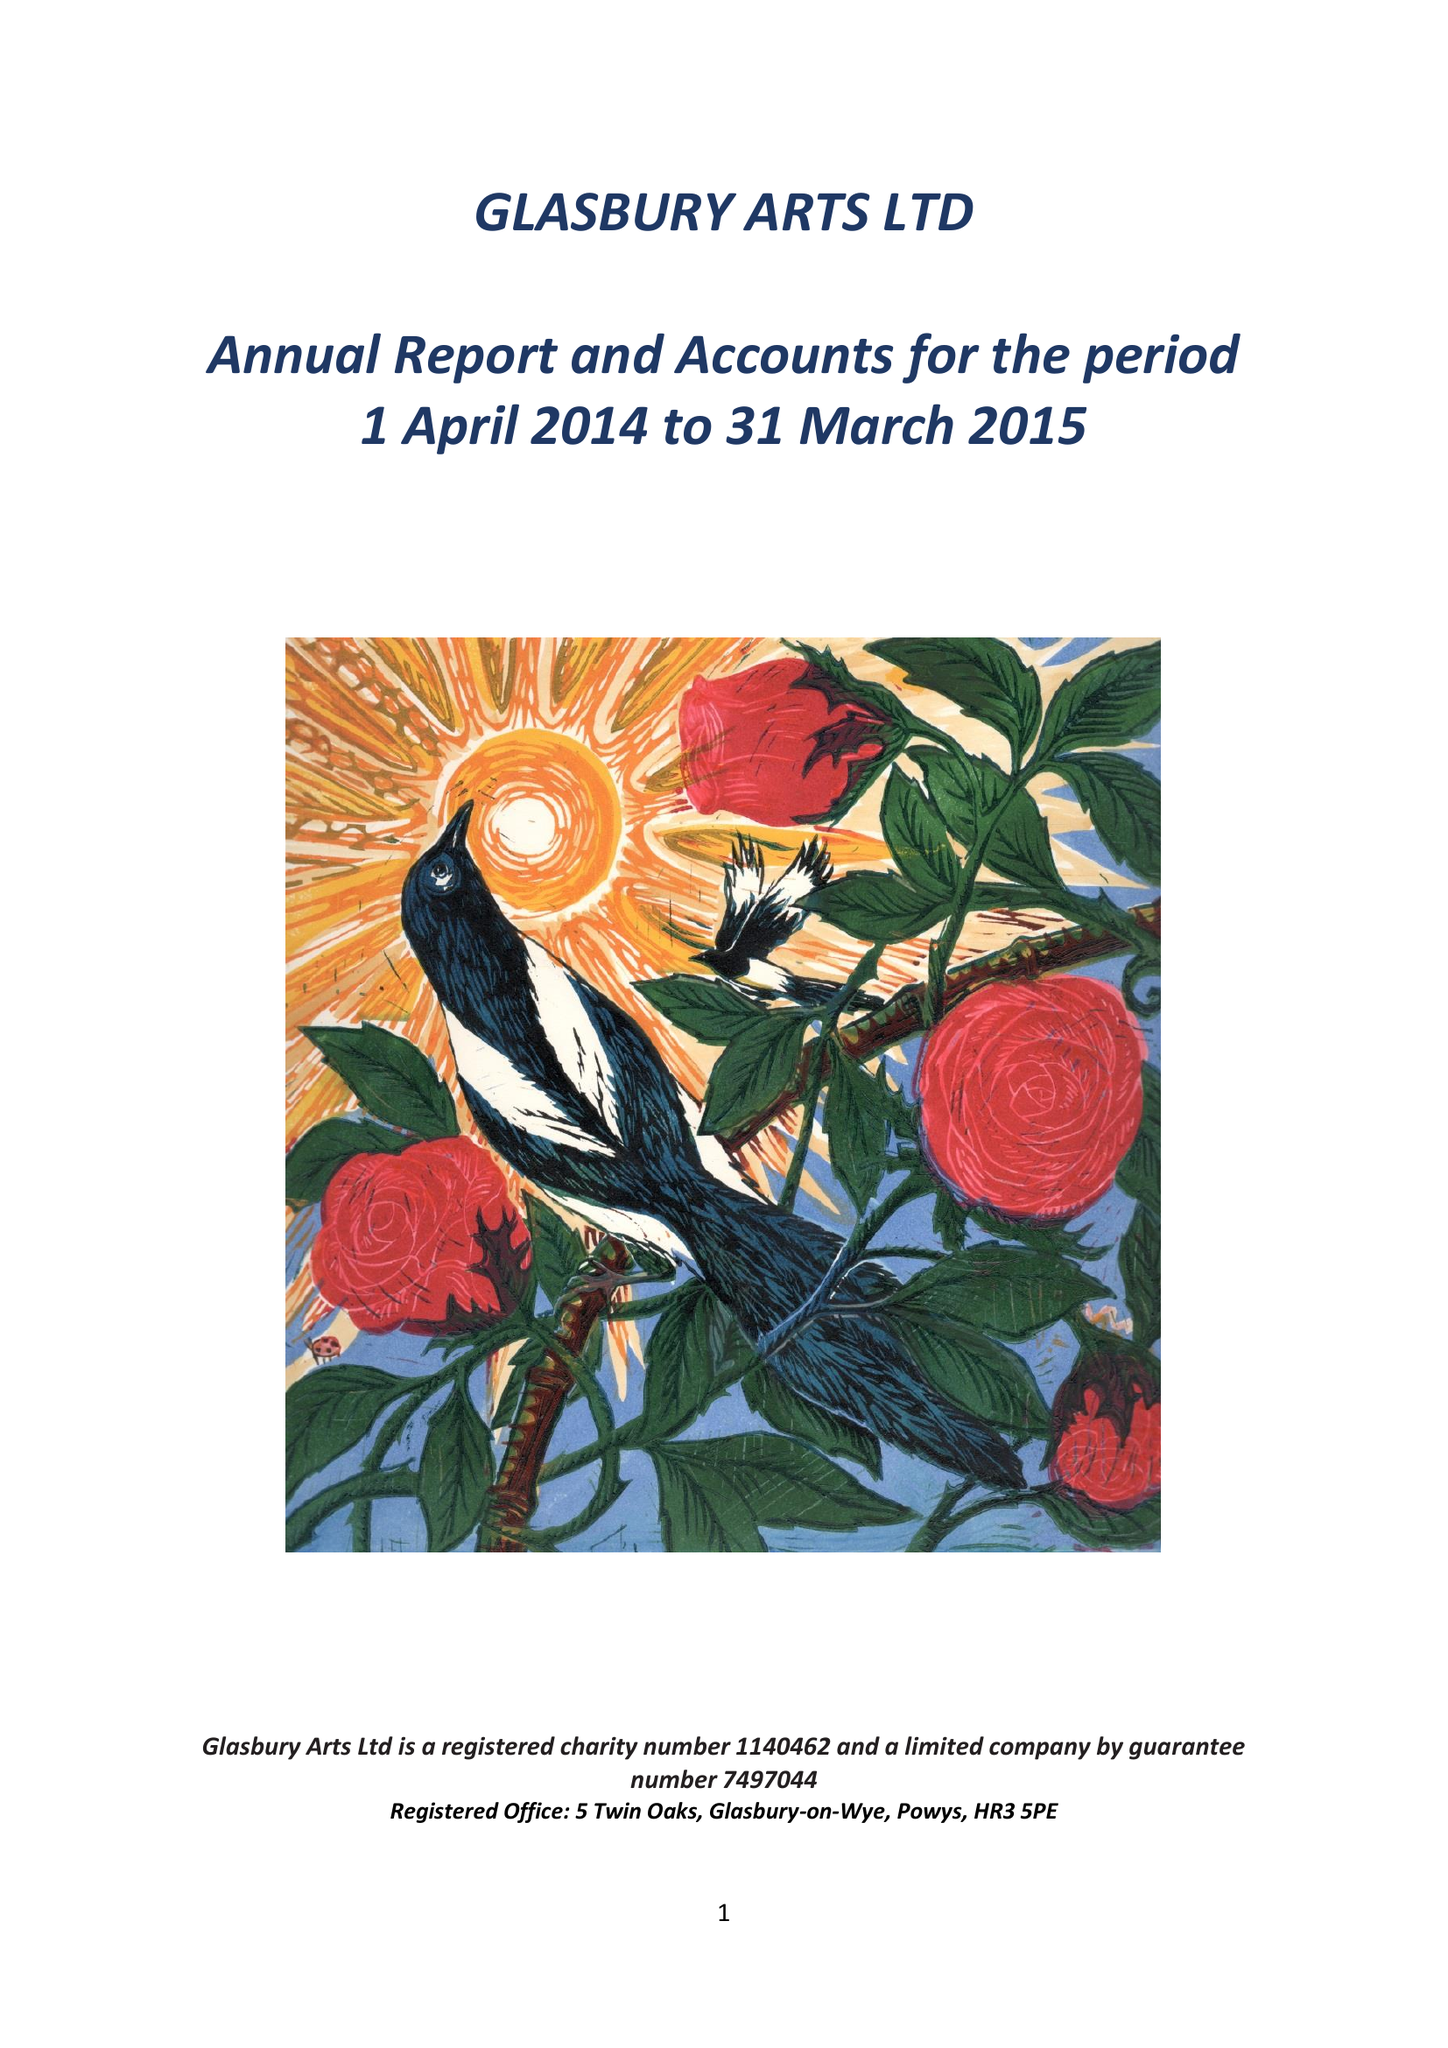What is the value for the report_date?
Answer the question using a single word or phrase. 2015-03-31 